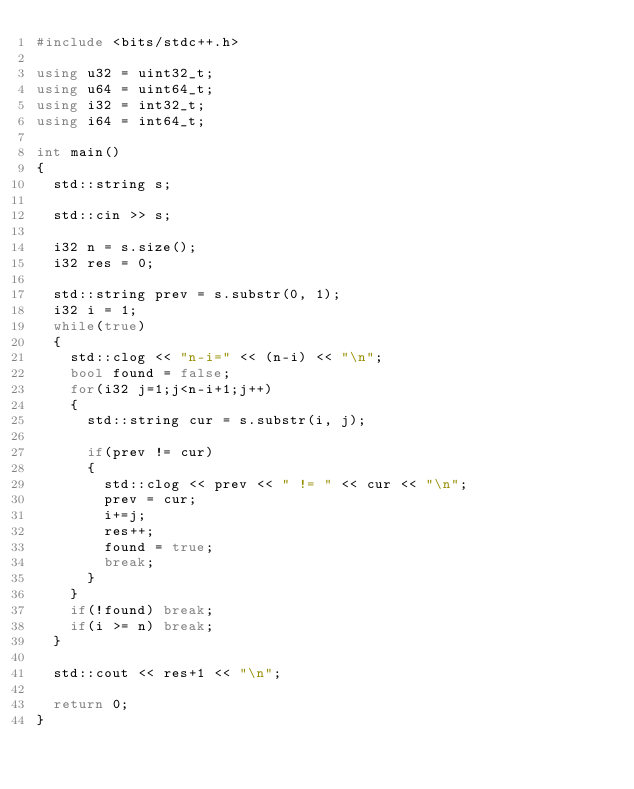<code> <loc_0><loc_0><loc_500><loc_500><_C++_>#include <bits/stdc++.h>

using u32 = uint32_t;
using u64 = uint64_t;
using i32 = int32_t;
using i64 = int64_t;

int main()
{
	std::string s;

	std::cin >> s;

	i32 n = s.size();
	i32 res = 0;

	std::string prev = s.substr(0, 1);
	i32 i = 1;
	while(true)
	{
		std::clog << "n-i=" << (n-i) << "\n";
		bool found = false;
		for(i32 j=1;j<n-i+1;j++)
		{
			std::string cur = s.substr(i, j);
			
			if(prev != cur)
			{
				std::clog << prev << " != " << cur << "\n";
				prev = cur;
				i+=j;
				res++;
				found = true;
				break;
			}
		}
		if(!found) break;
		if(i >= n) break;
	}

	std::cout << res+1 << "\n";
	
	return 0;
}</code> 